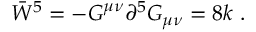Convert formula to latex. <formula><loc_0><loc_0><loc_500><loc_500>\bar { W } ^ { 5 } = - G ^ { \mu \nu } \partial ^ { 5 } G _ { \mu \nu } = 8 k \ .</formula> 